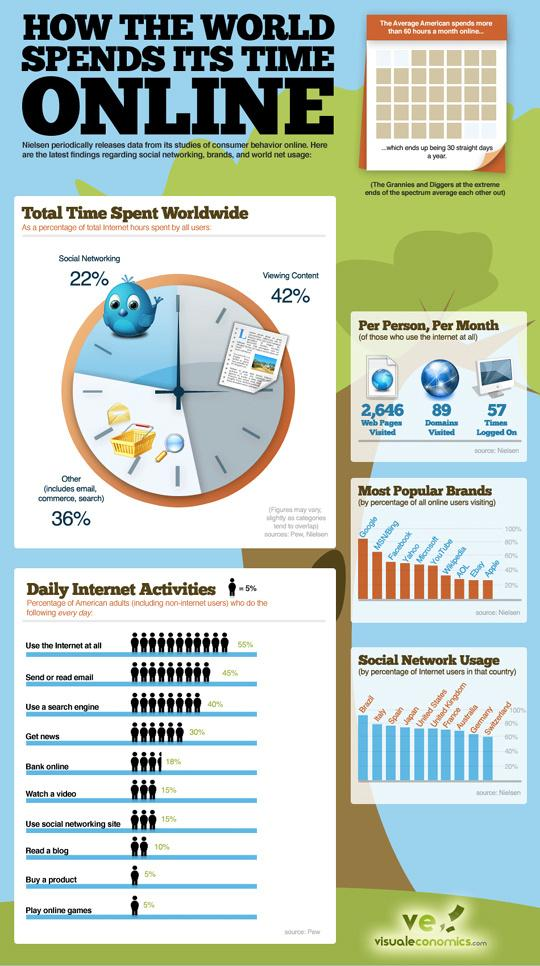Give some essential details in this illustration. According to a recent study, 42% of internet users worldwide spend time viewing content on the internet. A recent study revealed that 22% of internet users globally spend time on social networking sites. According to a recent survey, approximately 18% of American adults conduct online banking on a daily basis. Brazil has the highest percentage of internet users among the selected countries. According to recent statistics, approximately 5% of American adults play online games on a daily basis. 